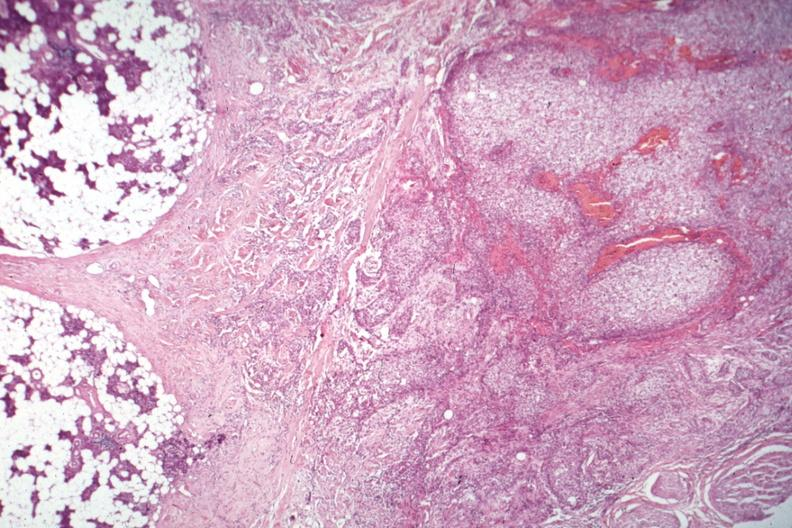where is this part in the figure?
Answer the question using a single word or phrase. Endocrine system 